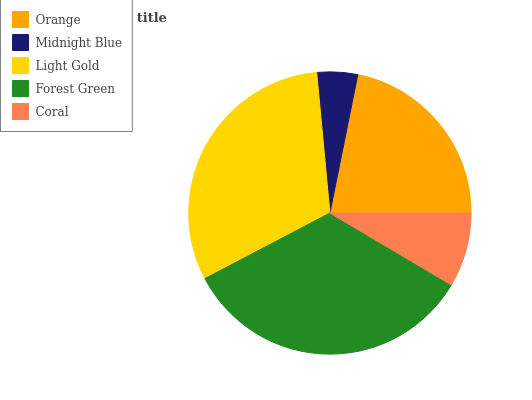Is Midnight Blue the minimum?
Answer yes or no. Yes. Is Forest Green the maximum?
Answer yes or no. Yes. Is Light Gold the minimum?
Answer yes or no. No. Is Light Gold the maximum?
Answer yes or no. No. Is Light Gold greater than Midnight Blue?
Answer yes or no. Yes. Is Midnight Blue less than Light Gold?
Answer yes or no. Yes. Is Midnight Blue greater than Light Gold?
Answer yes or no. No. Is Light Gold less than Midnight Blue?
Answer yes or no. No. Is Orange the high median?
Answer yes or no. Yes. Is Orange the low median?
Answer yes or no. Yes. Is Light Gold the high median?
Answer yes or no. No. Is Light Gold the low median?
Answer yes or no. No. 